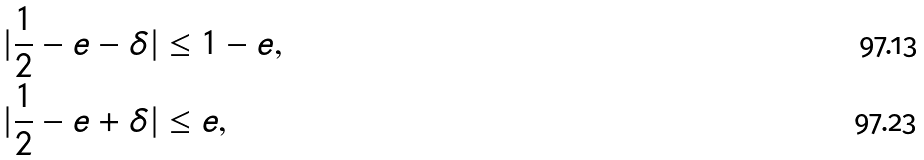<formula> <loc_0><loc_0><loc_500><loc_500>| \frac { 1 } { 2 } - e - \delta | & \leq 1 - e , \\ | \frac { 1 } { 2 } - e + \delta | & \leq e ,</formula> 